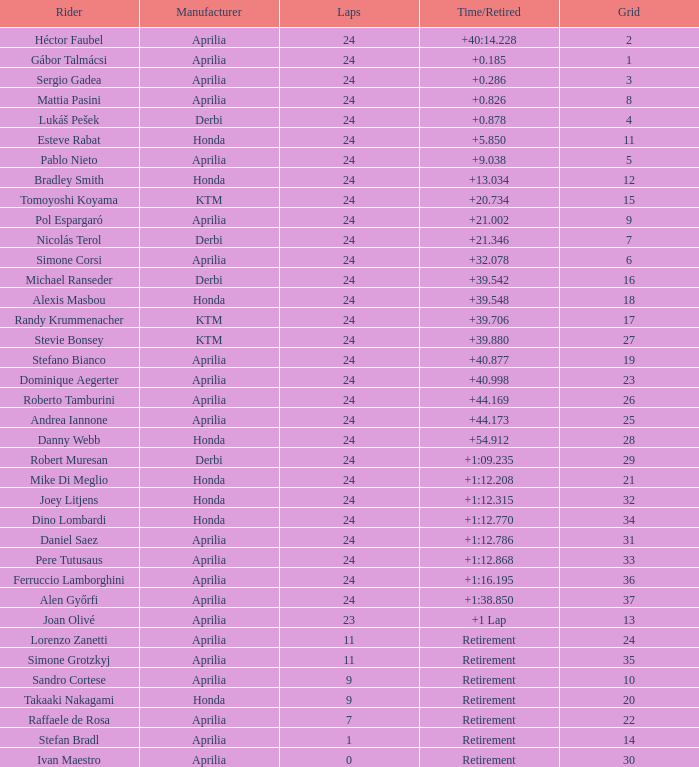Can you tell the time when given 10 grids? Retirement. 